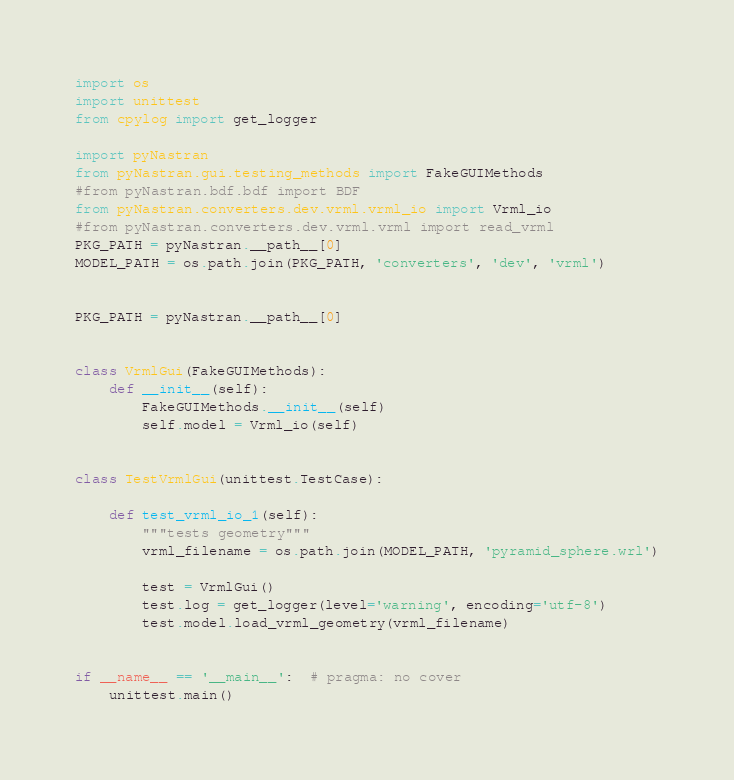Convert code to text. <code><loc_0><loc_0><loc_500><loc_500><_Python_>import os
import unittest
from cpylog import get_logger

import pyNastran
from pyNastran.gui.testing_methods import FakeGUIMethods
#from pyNastran.bdf.bdf import BDF
from pyNastran.converters.dev.vrml.vrml_io import Vrml_io
#from pyNastran.converters.dev.vrml.vrml import read_vrml
PKG_PATH = pyNastran.__path__[0]
MODEL_PATH = os.path.join(PKG_PATH, 'converters', 'dev', 'vrml')


PKG_PATH = pyNastran.__path__[0]


class VrmlGui(FakeGUIMethods):
    def __init__(self):
        FakeGUIMethods.__init__(self)
        self.model = Vrml_io(self)


class TestVrmlGui(unittest.TestCase):

    def test_vrml_io_1(self):
        """tests geometry"""
        vrml_filename = os.path.join(MODEL_PATH, 'pyramid_sphere.wrl')

        test = VrmlGui()
        test.log = get_logger(level='warning', encoding='utf-8')
        test.model.load_vrml_geometry(vrml_filename)


if __name__ == '__main__':  # pragma: no cover
    unittest.main()
</code> 